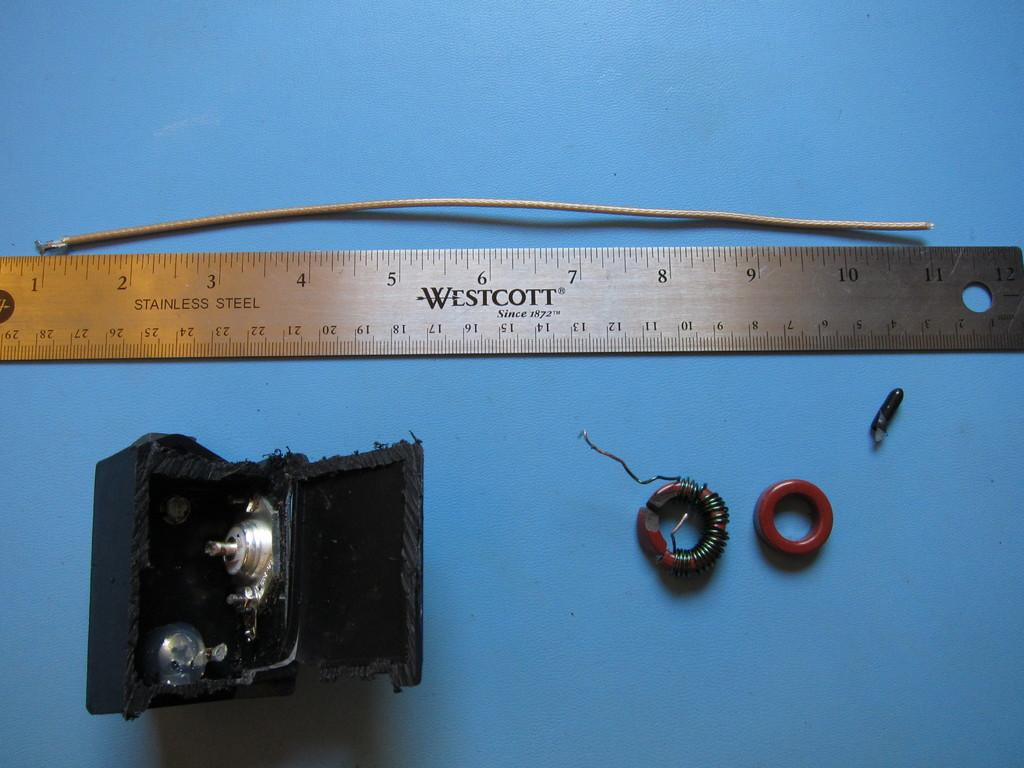<image>
Present a compact description of the photo's key features. A Westcott stainless steel ruler measures a piece of cable while other items are displayed below the ruler. 